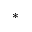<formula> <loc_0><loc_0><loc_500><loc_500>^ { * }</formula> 